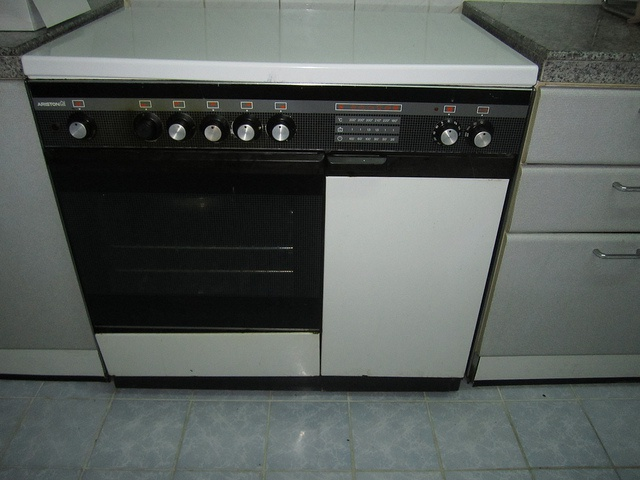Describe the objects in this image and their specific colors. I can see a oven in gray, black, and darkgray tones in this image. 